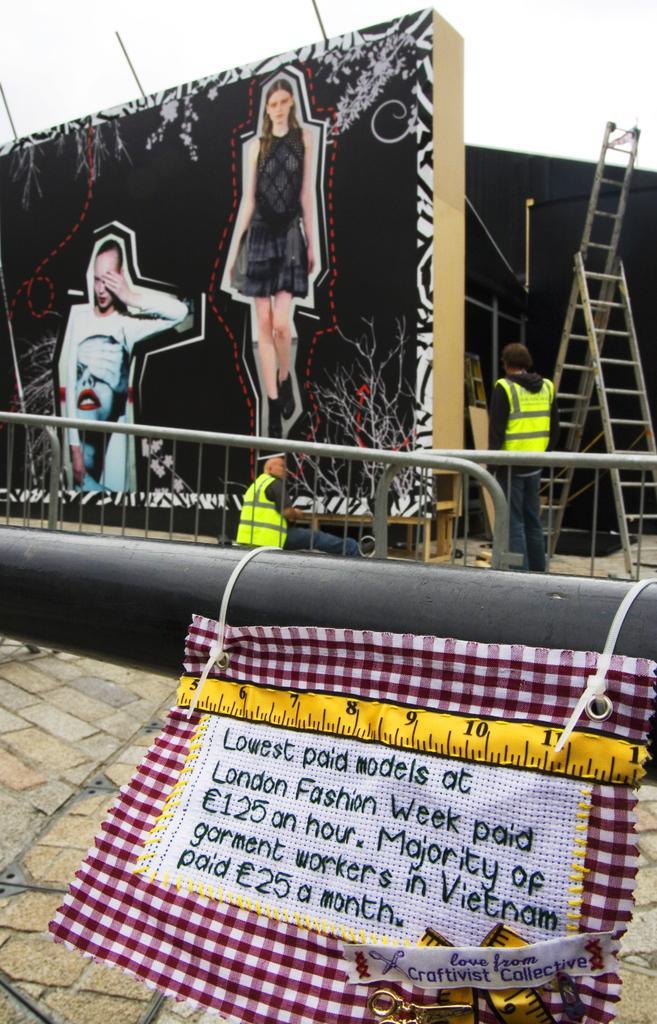Describe this image in one or two sentences. We can see cloth hanging on rod,on this cloth we can see text. In the background we can see people,pictures of women on board,ladder and sky. 